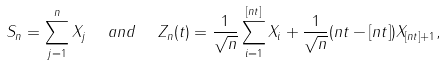<formula> <loc_0><loc_0><loc_500><loc_500>S _ { n } = \sum _ { j = 1 } ^ { n } X _ { j } \ \ a n d \ \ Z _ { n } ( t ) = \frac { 1 } { \sqrt { n } } \sum _ { i = 1 } ^ { [ n t ] } X _ { i } + \frac { 1 } { \sqrt { n } } ( n t - [ n t ] ) X _ { [ n t ] + 1 } ,</formula> 